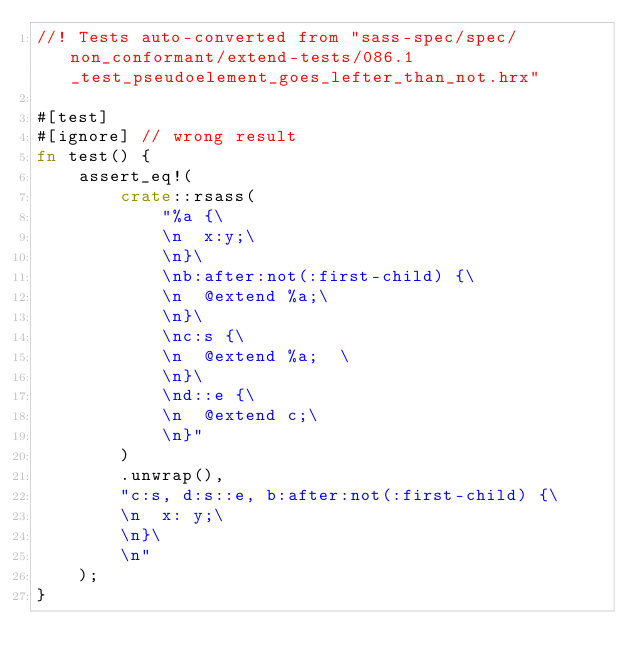<code> <loc_0><loc_0><loc_500><loc_500><_Rust_>//! Tests auto-converted from "sass-spec/spec/non_conformant/extend-tests/086.1_test_pseudoelement_goes_lefter_than_not.hrx"

#[test]
#[ignore] // wrong result
fn test() {
    assert_eq!(
        crate::rsass(
            "%a {\
            \n  x:y;\
            \n}\
            \nb:after:not(:first-child) {\
            \n  @extend %a;\
            \n}\
            \nc:s {\
            \n  @extend %a;  \
            \n}\
            \nd::e {\
            \n  @extend c;\
            \n}"
        )
        .unwrap(),
        "c:s, d:s::e, b:after:not(:first-child) {\
        \n  x: y;\
        \n}\
        \n"
    );
}
</code> 